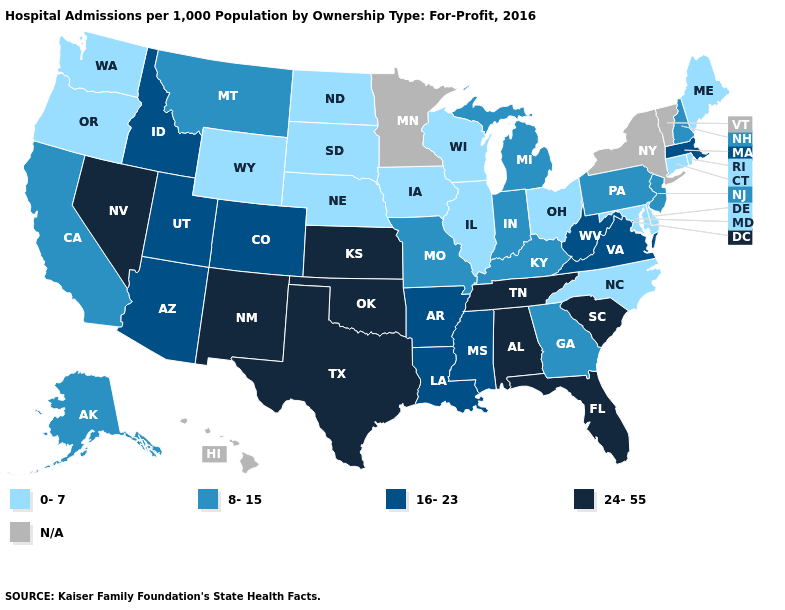Is the legend a continuous bar?
Be succinct. No. What is the value of Maryland?
Be succinct. 0-7. What is the lowest value in the USA?
Answer briefly. 0-7. How many symbols are there in the legend?
Answer briefly. 5. Name the states that have a value in the range 0-7?
Keep it brief. Connecticut, Delaware, Illinois, Iowa, Maine, Maryland, Nebraska, North Carolina, North Dakota, Ohio, Oregon, Rhode Island, South Dakota, Washington, Wisconsin, Wyoming. Name the states that have a value in the range 8-15?
Be succinct. Alaska, California, Georgia, Indiana, Kentucky, Michigan, Missouri, Montana, New Hampshire, New Jersey, Pennsylvania. What is the value of Kentucky?
Be succinct. 8-15. Among the states that border Ohio , does Pennsylvania have the lowest value?
Give a very brief answer. Yes. What is the value of New York?
Be succinct. N/A. What is the value of Iowa?
Be succinct. 0-7. What is the highest value in the USA?
Give a very brief answer. 24-55. How many symbols are there in the legend?
Be succinct. 5. 